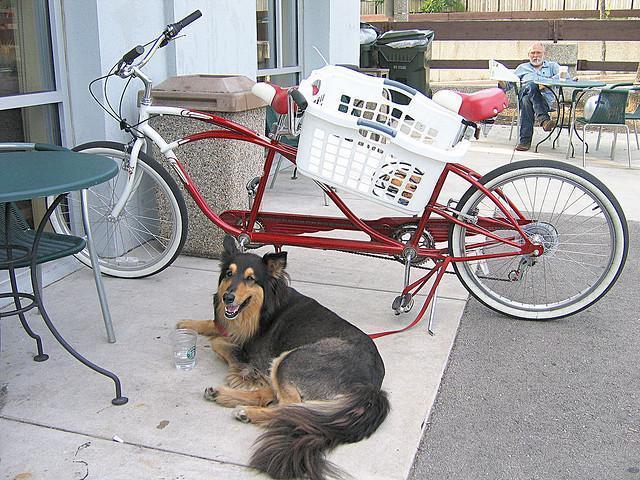How many dining tables can you see?
Give a very brief answer. 2. How many cats are there?
Give a very brief answer. 0. 